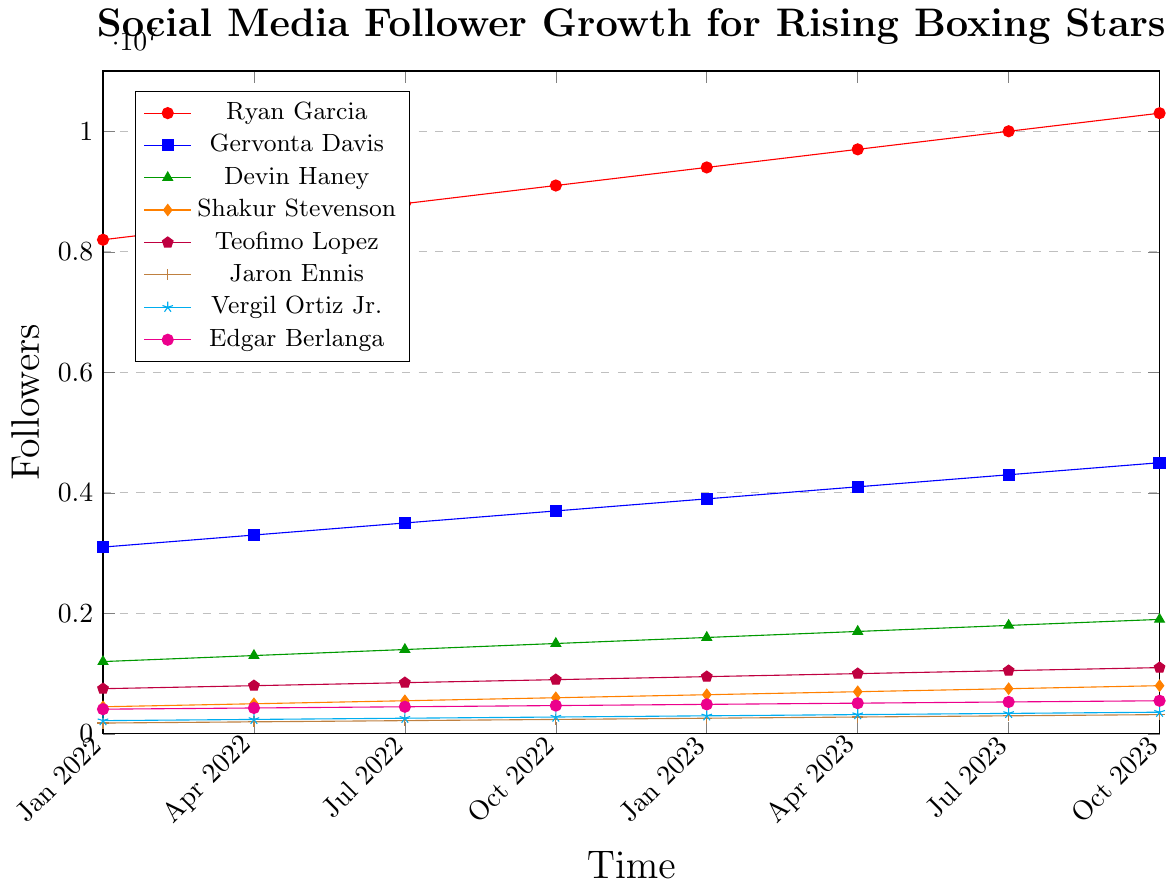Which boxer had the highest number of followers in October 2023? Ryan Garcia had the highest number of followers in October 2023 as indicated by his data point reaching 10,300,000 followers.
Answer: Ryan Garcia Between Gervonta Davis and Devin Haney, who gained more followers over the period from January 2022 to October 2023? Gervonta Davis started with 3,100,000 followers and ended with 4,500,000, gaining 1,400,000 followers. Devin Haney started with 1,200,000 followers and ended with 1,900,000, gaining 700,000 followers. Therefore, Gervonta Davis gained more followers.
Answer: Gervonta Davis What is the total number of followers gained by Jaron Ennis from January 2022 to October 2023? Jaron Ennis started with 180,000 followers in January 2022 and reached 320,000 followers by October 2023. The total number of followers gained is 320,000 - 180,000 = 140,000.
Answer: 140,000 Which two boxers had the closest number of followers in April 2023 and what were their follower counts? In April 2023, Teofimo Lopez and Edgar Berlanga had close follower counts: Teofimo Lopez with 1,000,000 and Edgar Berlanga with 510,000 followers. While the absolute follower numbers are not very close, these two are closest among the given boxers.
Answer: Teofimo Lopez with 1,000,000 and Edgar Berlanga with 510,000 Which boxer had the smallest absolute gain in followers from January 2022 to October 2023? The smallest absolute gain in followers from January 2022 to October 2023 is calculated for each boxer and it is Shakur Stevenson with an increase from 450,000 to 800,000, which is an absolute gain of 350,000 followers.
Answer: Shakur Stevenson 